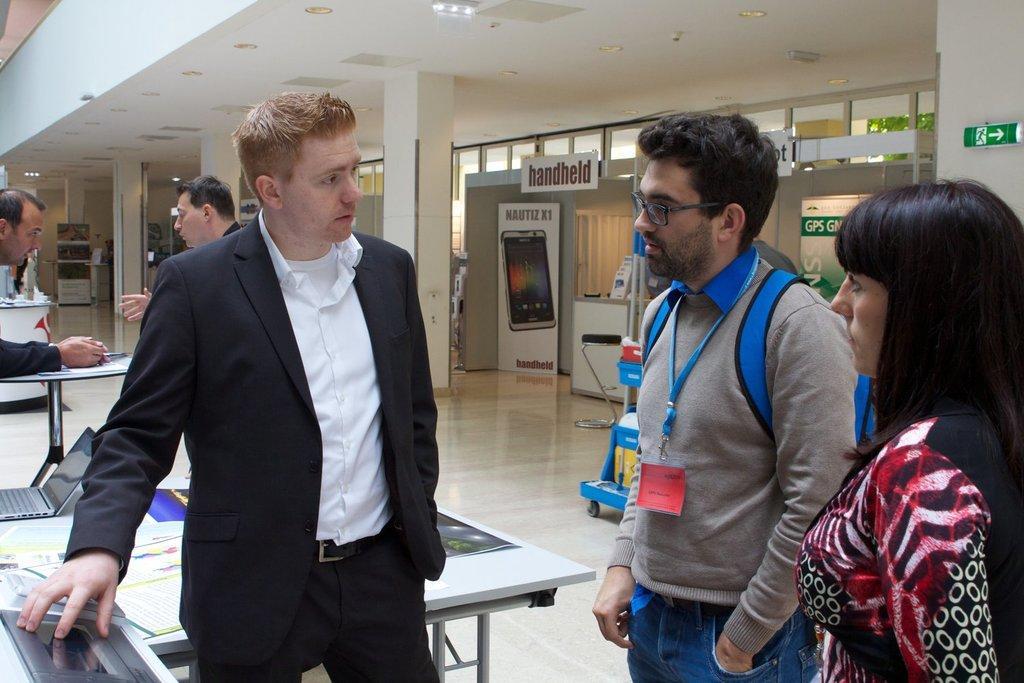How would you summarize this image in a sentence or two? In the picture I can see a man on the left side and he is wearing a suit. I can see a man on the right side wearing a sweater and he is carrying a bag on his back. There is a tag on his neck. I can see a woman on the right side. I can see two men on the left side having a conversation. I can see the banner board. There is a lighting arrangement on the roof and I can see the pillars. 